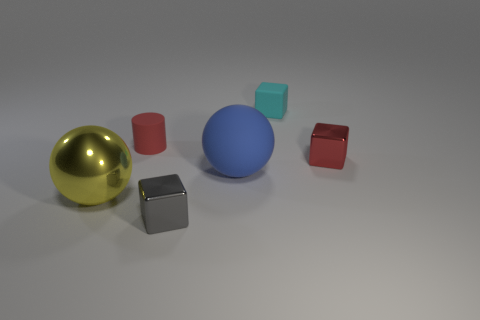Can you tell me what objects are present in the image and their colors? The image showcases an assortment of objects including a glossy golden sphere, a matte red cylinder, a matte blue sphere, translucent light blue and red cubes, and a matte grey cube. 